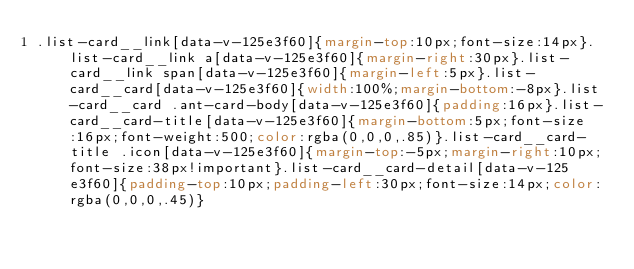<code> <loc_0><loc_0><loc_500><loc_500><_CSS_>.list-card__link[data-v-125e3f60]{margin-top:10px;font-size:14px}.list-card__link a[data-v-125e3f60]{margin-right:30px}.list-card__link span[data-v-125e3f60]{margin-left:5px}.list-card__card[data-v-125e3f60]{width:100%;margin-bottom:-8px}.list-card__card .ant-card-body[data-v-125e3f60]{padding:16px}.list-card__card-title[data-v-125e3f60]{margin-bottom:5px;font-size:16px;font-weight:500;color:rgba(0,0,0,.85)}.list-card__card-title .icon[data-v-125e3f60]{margin-top:-5px;margin-right:10px;font-size:38px!important}.list-card__card-detail[data-v-125e3f60]{padding-top:10px;padding-left:30px;font-size:14px;color:rgba(0,0,0,.45)}</code> 